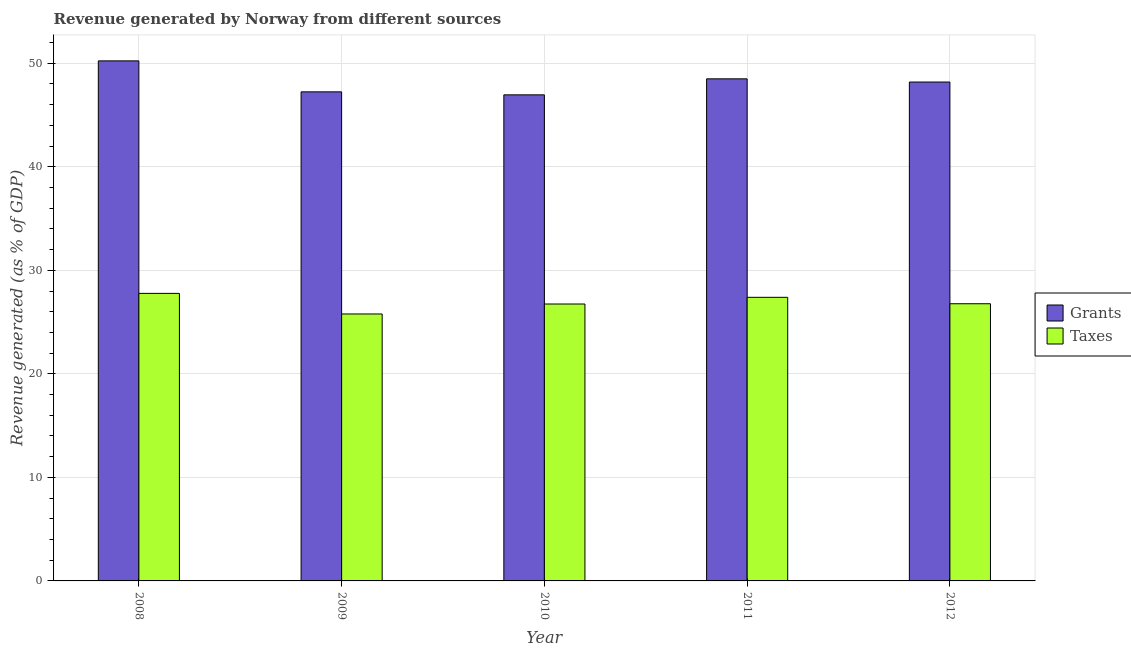How many different coloured bars are there?
Your answer should be compact. 2. Are the number of bars on each tick of the X-axis equal?
Ensure brevity in your answer.  Yes. How many bars are there on the 3rd tick from the left?
Provide a succinct answer. 2. What is the label of the 2nd group of bars from the left?
Make the answer very short. 2009. What is the revenue generated by taxes in 2009?
Your answer should be compact. 25.78. Across all years, what is the maximum revenue generated by grants?
Offer a very short reply. 50.23. Across all years, what is the minimum revenue generated by grants?
Your answer should be very brief. 46.94. In which year was the revenue generated by grants maximum?
Your response must be concise. 2008. What is the total revenue generated by taxes in the graph?
Make the answer very short. 134.46. What is the difference between the revenue generated by grants in 2010 and that in 2012?
Provide a short and direct response. -1.24. What is the difference between the revenue generated by grants in 2010 and the revenue generated by taxes in 2009?
Keep it short and to the point. -0.29. What is the average revenue generated by grants per year?
Make the answer very short. 48.22. In how many years, is the revenue generated by grants greater than 10 %?
Your answer should be very brief. 5. What is the ratio of the revenue generated by grants in 2008 to that in 2011?
Give a very brief answer. 1.04. What is the difference between the highest and the second highest revenue generated by taxes?
Make the answer very short. 0.38. What is the difference between the highest and the lowest revenue generated by grants?
Your answer should be compact. 3.28. In how many years, is the revenue generated by taxes greater than the average revenue generated by taxes taken over all years?
Keep it short and to the point. 2. What does the 1st bar from the left in 2010 represents?
Provide a succinct answer. Grants. What does the 1st bar from the right in 2009 represents?
Make the answer very short. Taxes. How many bars are there?
Give a very brief answer. 10. How many years are there in the graph?
Ensure brevity in your answer.  5. What is the difference between two consecutive major ticks on the Y-axis?
Your answer should be very brief. 10. Does the graph contain grids?
Ensure brevity in your answer.  Yes. What is the title of the graph?
Make the answer very short. Revenue generated by Norway from different sources. What is the label or title of the X-axis?
Provide a short and direct response. Year. What is the label or title of the Y-axis?
Your answer should be compact. Revenue generated (as % of GDP). What is the Revenue generated (as % of GDP) of Grants in 2008?
Keep it short and to the point. 50.23. What is the Revenue generated (as % of GDP) of Taxes in 2008?
Offer a terse response. 27.77. What is the Revenue generated (as % of GDP) of Grants in 2009?
Provide a short and direct response. 47.23. What is the Revenue generated (as % of GDP) of Taxes in 2009?
Ensure brevity in your answer.  25.78. What is the Revenue generated (as % of GDP) in Grants in 2010?
Keep it short and to the point. 46.94. What is the Revenue generated (as % of GDP) of Taxes in 2010?
Offer a terse response. 26.74. What is the Revenue generated (as % of GDP) in Grants in 2011?
Make the answer very short. 48.49. What is the Revenue generated (as % of GDP) of Taxes in 2011?
Offer a terse response. 27.39. What is the Revenue generated (as % of GDP) of Grants in 2012?
Make the answer very short. 48.18. What is the Revenue generated (as % of GDP) in Taxes in 2012?
Make the answer very short. 26.77. Across all years, what is the maximum Revenue generated (as % of GDP) in Grants?
Ensure brevity in your answer.  50.23. Across all years, what is the maximum Revenue generated (as % of GDP) in Taxes?
Offer a very short reply. 27.77. Across all years, what is the minimum Revenue generated (as % of GDP) in Grants?
Provide a succinct answer. 46.94. Across all years, what is the minimum Revenue generated (as % of GDP) in Taxes?
Your answer should be compact. 25.78. What is the total Revenue generated (as % of GDP) of Grants in the graph?
Give a very brief answer. 241.08. What is the total Revenue generated (as % of GDP) in Taxes in the graph?
Your response must be concise. 134.46. What is the difference between the Revenue generated (as % of GDP) of Grants in 2008 and that in 2009?
Offer a very short reply. 2.99. What is the difference between the Revenue generated (as % of GDP) in Taxes in 2008 and that in 2009?
Make the answer very short. 1.99. What is the difference between the Revenue generated (as % of GDP) of Grants in 2008 and that in 2010?
Offer a terse response. 3.28. What is the difference between the Revenue generated (as % of GDP) in Taxes in 2008 and that in 2010?
Your answer should be very brief. 1.03. What is the difference between the Revenue generated (as % of GDP) of Grants in 2008 and that in 2011?
Make the answer very short. 1.73. What is the difference between the Revenue generated (as % of GDP) of Taxes in 2008 and that in 2011?
Your answer should be very brief. 0.38. What is the difference between the Revenue generated (as % of GDP) in Grants in 2008 and that in 2012?
Offer a terse response. 2.04. What is the difference between the Revenue generated (as % of GDP) in Grants in 2009 and that in 2010?
Provide a short and direct response. 0.29. What is the difference between the Revenue generated (as % of GDP) of Taxes in 2009 and that in 2010?
Provide a succinct answer. -0.96. What is the difference between the Revenue generated (as % of GDP) of Grants in 2009 and that in 2011?
Your answer should be compact. -1.26. What is the difference between the Revenue generated (as % of GDP) of Taxes in 2009 and that in 2011?
Give a very brief answer. -1.61. What is the difference between the Revenue generated (as % of GDP) in Grants in 2009 and that in 2012?
Ensure brevity in your answer.  -0.95. What is the difference between the Revenue generated (as % of GDP) of Taxes in 2009 and that in 2012?
Offer a terse response. -0.99. What is the difference between the Revenue generated (as % of GDP) of Grants in 2010 and that in 2011?
Your response must be concise. -1.55. What is the difference between the Revenue generated (as % of GDP) of Taxes in 2010 and that in 2011?
Provide a succinct answer. -0.65. What is the difference between the Revenue generated (as % of GDP) of Grants in 2010 and that in 2012?
Your answer should be compact. -1.24. What is the difference between the Revenue generated (as % of GDP) in Taxes in 2010 and that in 2012?
Give a very brief answer. -0.03. What is the difference between the Revenue generated (as % of GDP) in Grants in 2011 and that in 2012?
Make the answer very short. 0.31. What is the difference between the Revenue generated (as % of GDP) of Taxes in 2011 and that in 2012?
Ensure brevity in your answer.  0.62. What is the difference between the Revenue generated (as % of GDP) of Grants in 2008 and the Revenue generated (as % of GDP) of Taxes in 2009?
Provide a succinct answer. 24.44. What is the difference between the Revenue generated (as % of GDP) in Grants in 2008 and the Revenue generated (as % of GDP) in Taxes in 2010?
Your answer should be very brief. 23.48. What is the difference between the Revenue generated (as % of GDP) of Grants in 2008 and the Revenue generated (as % of GDP) of Taxes in 2011?
Make the answer very short. 22.84. What is the difference between the Revenue generated (as % of GDP) in Grants in 2008 and the Revenue generated (as % of GDP) in Taxes in 2012?
Your response must be concise. 23.46. What is the difference between the Revenue generated (as % of GDP) in Grants in 2009 and the Revenue generated (as % of GDP) in Taxes in 2010?
Offer a very short reply. 20.49. What is the difference between the Revenue generated (as % of GDP) of Grants in 2009 and the Revenue generated (as % of GDP) of Taxes in 2011?
Provide a short and direct response. 19.84. What is the difference between the Revenue generated (as % of GDP) in Grants in 2009 and the Revenue generated (as % of GDP) in Taxes in 2012?
Provide a succinct answer. 20.46. What is the difference between the Revenue generated (as % of GDP) in Grants in 2010 and the Revenue generated (as % of GDP) in Taxes in 2011?
Your answer should be compact. 19.55. What is the difference between the Revenue generated (as % of GDP) of Grants in 2010 and the Revenue generated (as % of GDP) of Taxes in 2012?
Keep it short and to the point. 20.17. What is the difference between the Revenue generated (as % of GDP) in Grants in 2011 and the Revenue generated (as % of GDP) in Taxes in 2012?
Offer a terse response. 21.72. What is the average Revenue generated (as % of GDP) of Grants per year?
Make the answer very short. 48.22. What is the average Revenue generated (as % of GDP) of Taxes per year?
Ensure brevity in your answer.  26.89. In the year 2008, what is the difference between the Revenue generated (as % of GDP) in Grants and Revenue generated (as % of GDP) in Taxes?
Give a very brief answer. 22.46. In the year 2009, what is the difference between the Revenue generated (as % of GDP) of Grants and Revenue generated (as % of GDP) of Taxes?
Offer a terse response. 21.45. In the year 2010, what is the difference between the Revenue generated (as % of GDP) in Grants and Revenue generated (as % of GDP) in Taxes?
Your answer should be very brief. 20.2. In the year 2011, what is the difference between the Revenue generated (as % of GDP) of Grants and Revenue generated (as % of GDP) of Taxes?
Provide a short and direct response. 21.1. In the year 2012, what is the difference between the Revenue generated (as % of GDP) in Grants and Revenue generated (as % of GDP) in Taxes?
Your answer should be very brief. 21.41. What is the ratio of the Revenue generated (as % of GDP) of Grants in 2008 to that in 2009?
Provide a succinct answer. 1.06. What is the ratio of the Revenue generated (as % of GDP) in Taxes in 2008 to that in 2009?
Provide a short and direct response. 1.08. What is the ratio of the Revenue generated (as % of GDP) in Grants in 2008 to that in 2010?
Your response must be concise. 1.07. What is the ratio of the Revenue generated (as % of GDP) of Taxes in 2008 to that in 2010?
Make the answer very short. 1.04. What is the ratio of the Revenue generated (as % of GDP) of Grants in 2008 to that in 2011?
Keep it short and to the point. 1.04. What is the ratio of the Revenue generated (as % of GDP) of Taxes in 2008 to that in 2011?
Offer a very short reply. 1.01. What is the ratio of the Revenue generated (as % of GDP) in Grants in 2008 to that in 2012?
Your answer should be compact. 1.04. What is the ratio of the Revenue generated (as % of GDP) of Taxes in 2008 to that in 2012?
Provide a succinct answer. 1.04. What is the ratio of the Revenue generated (as % of GDP) in Grants in 2009 to that in 2010?
Your answer should be very brief. 1.01. What is the ratio of the Revenue generated (as % of GDP) in Taxes in 2009 to that in 2010?
Provide a short and direct response. 0.96. What is the ratio of the Revenue generated (as % of GDP) of Grants in 2009 to that in 2011?
Offer a terse response. 0.97. What is the ratio of the Revenue generated (as % of GDP) in Taxes in 2009 to that in 2011?
Ensure brevity in your answer.  0.94. What is the ratio of the Revenue generated (as % of GDP) of Grants in 2009 to that in 2012?
Your answer should be very brief. 0.98. What is the ratio of the Revenue generated (as % of GDP) in Taxes in 2009 to that in 2012?
Offer a terse response. 0.96. What is the ratio of the Revenue generated (as % of GDP) in Grants in 2010 to that in 2011?
Give a very brief answer. 0.97. What is the ratio of the Revenue generated (as % of GDP) in Taxes in 2010 to that in 2011?
Your response must be concise. 0.98. What is the ratio of the Revenue generated (as % of GDP) in Grants in 2010 to that in 2012?
Ensure brevity in your answer.  0.97. What is the ratio of the Revenue generated (as % of GDP) in Taxes in 2010 to that in 2012?
Make the answer very short. 1. What is the ratio of the Revenue generated (as % of GDP) of Grants in 2011 to that in 2012?
Keep it short and to the point. 1.01. What is the ratio of the Revenue generated (as % of GDP) of Taxes in 2011 to that in 2012?
Ensure brevity in your answer.  1.02. What is the difference between the highest and the second highest Revenue generated (as % of GDP) in Grants?
Your answer should be very brief. 1.73. What is the difference between the highest and the second highest Revenue generated (as % of GDP) in Taxes?
Ensure brevity in your answer.  0.38. What is the difference between the highest and the lowest Revenue generated (as % of GDP) of Grants?
Ensure brevity in your answer.  3.28. What is the difference between the highest and the lowest Revenue generated (as % of GDP) of Taxes?
Provide a succinct answer. 1.99. 